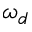Convert formula to latex. <formula><loc_0><loc_0><loc_500><loc_500>\omega _ { d }</formula> 